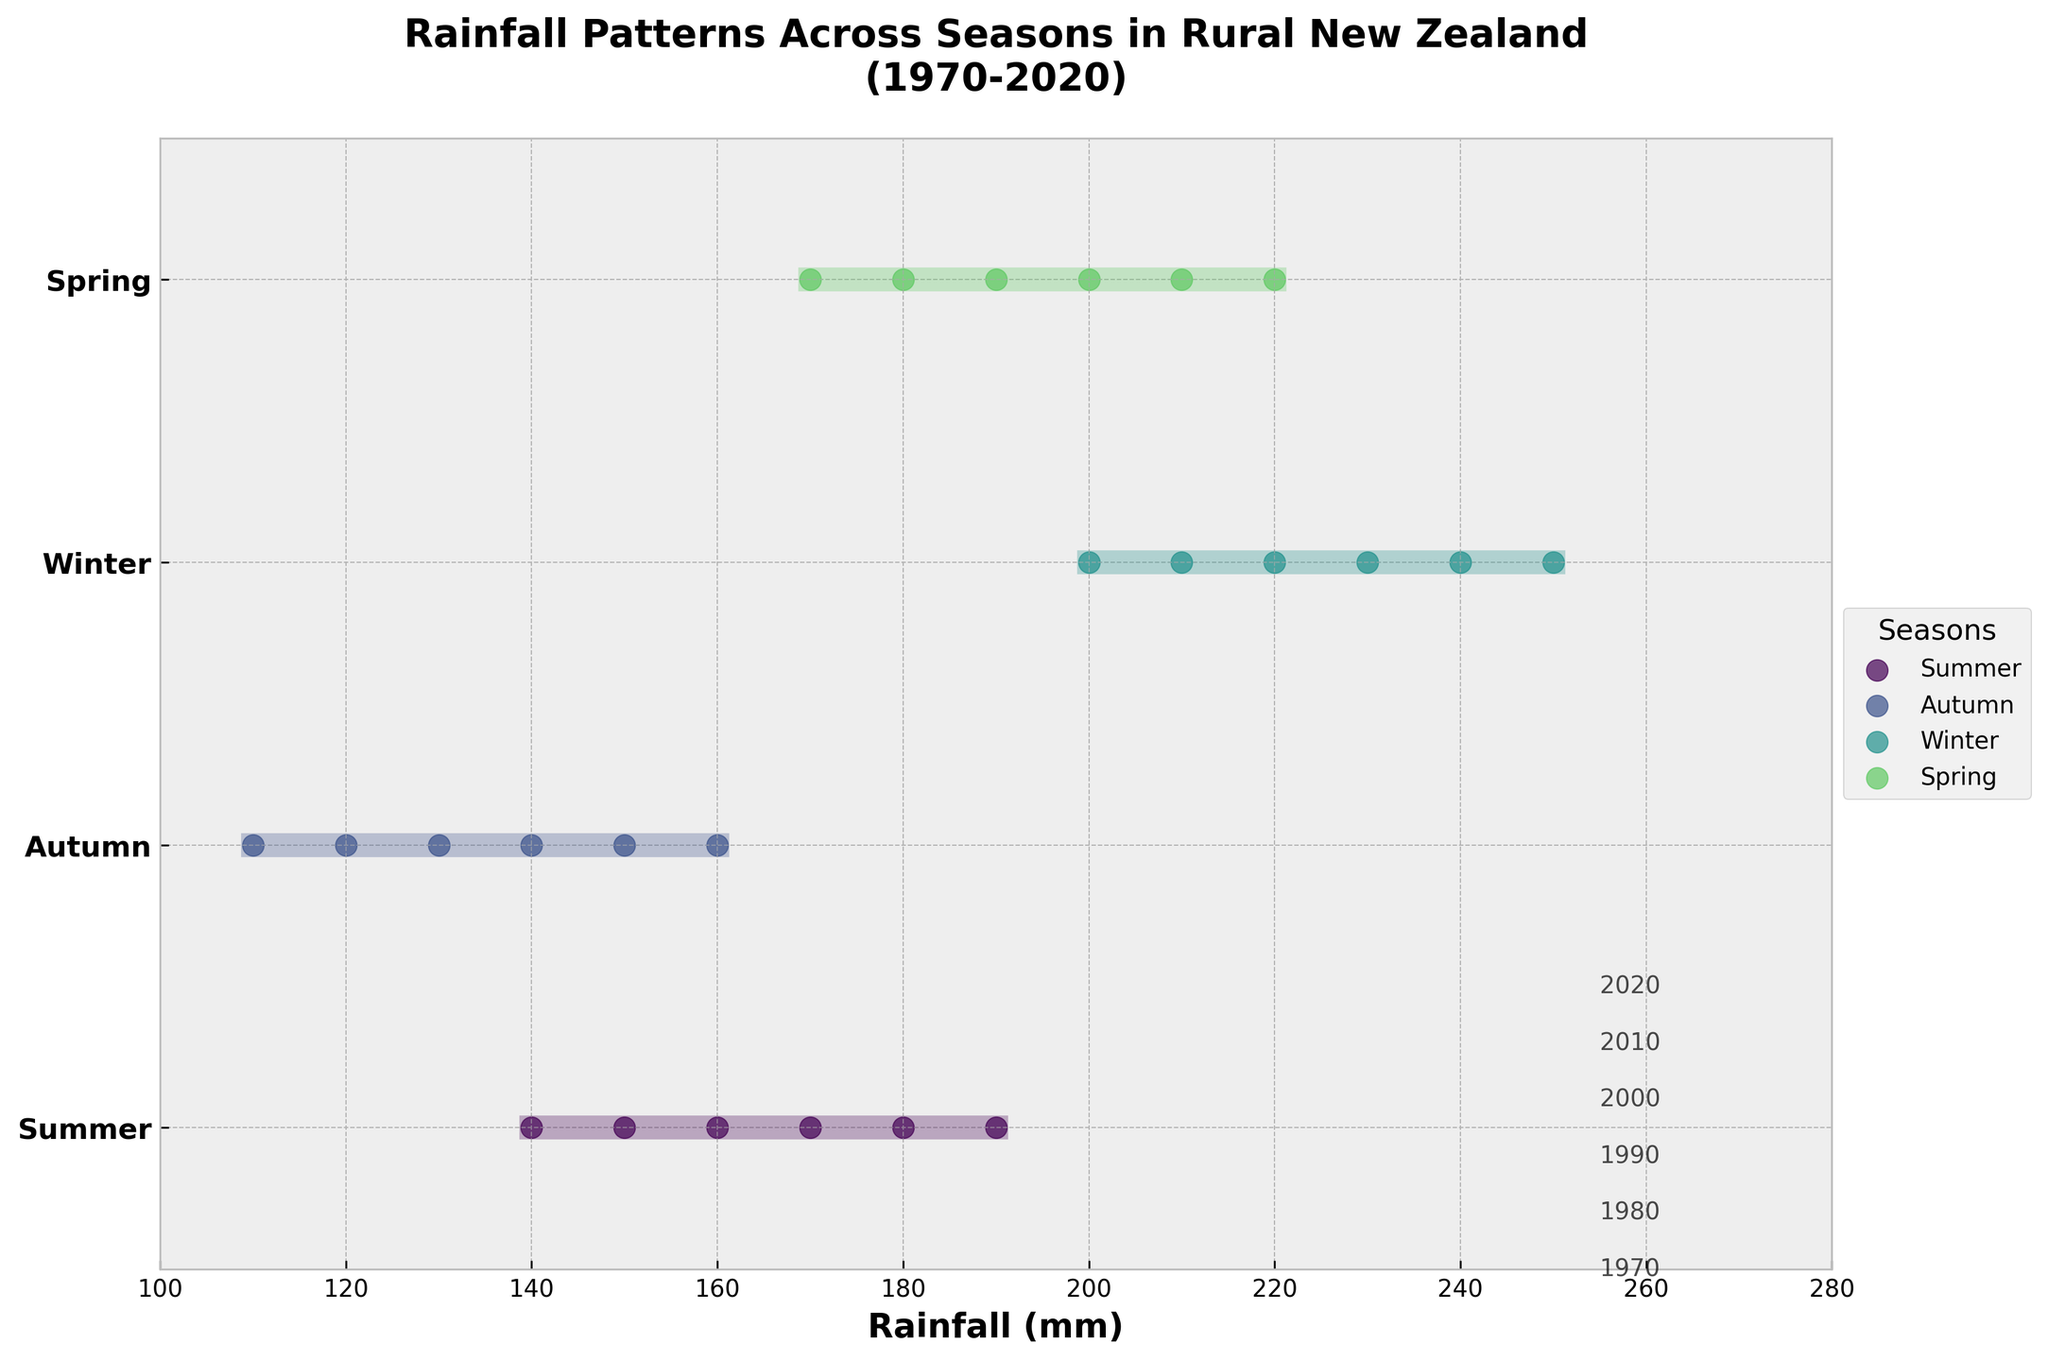What is the title of the figure? The title is usually found at the top of the figure, providing a summary of what the plot represents. Here it indicates the nature and scope of the plot.
Answer: Rainfall Patterns Across Seasons in Rural New Zealand (1970-2020) How many seasons are represented in the plot? Each season is represented by a different line and marker color on the Y-axis. By counting the labeled points on the Y-axis, we can determine the number of seasons.
Answer: 4 Which season had the highest recorded rainfall over the years? We compare the maximum rainfall values (the farthest right points) for each of the seasons. Winter has the highest maximum rainfall value.
Answer: Winter What is the range of rainfall values for Summer? Referring to the horizontal span of the Summer points, calculate the difference between the maximum and minimum values for this season. Summer's range is represented by the distance between its leftmost and rightmost dots.
Answer: 40 mm Which season shows the least variability in rainfall? Variability can be determined by comparing the horizontal lengths (ranges) of the rainfall spans for each season. The season with the shortest range has the least variability.
Answer: Autumn What are the rainfall values for Spring in the year 1980? Look for the Spring season dots and identify the one corresponding to the year 1980. The specific rainfall value at this point is what we're interested in.
Answer: 190 mm Which season has a steadily increasing rainfall trend over the years? Examine the positions of the dots for each season over the years to see if they show a consistent upward trend. Spring's dots move to the right over time, indicating increasing rainfall.
Answer: Spring What is the difference in maximum rainfall between Summer and Winter? Identify the maximum rainfall values for both Summer and Winter from their respective lines; then, subtract the Summer maximum from the Winter maximum.
Answer: 100 mm Between which years did Summer see the largest increase in rainfall? Look at the rainfall values for Summer across different years and find the pair of years with the largest positive difference (i.e., the newest year minus the oldest in the selected pairs).
Answer: 2000 to 2010 Which season consistently has lower rainfall compared to others? Compare the positions of the dots among the seasons across all years. Autumn generally places its dots further to the left (lower values) relative to others.
Answer: Autumn 